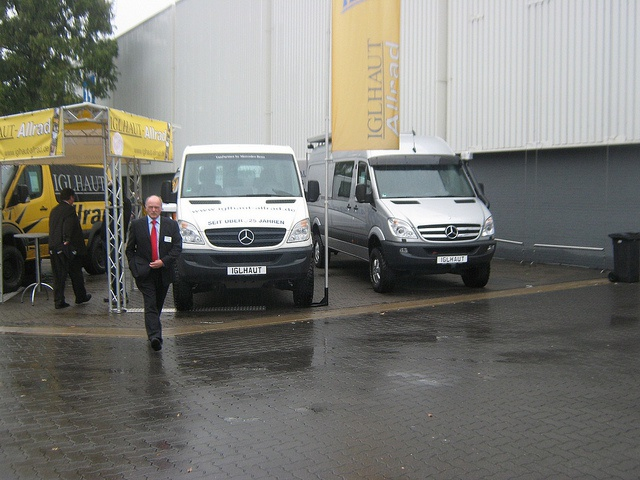Describe the objects in this image and their specific colors. I can see truck in darkgreen, black, gray, darkgray, and lightgray tones, truck in darkgreen, white, black, darkgray, and gray tones, truck in darkgreen, black, gray, and olive tones, people in darkgreen, black, gray, and brown tones, and people in darkgreen, black, maroon, gray, and olive tones in this image. 